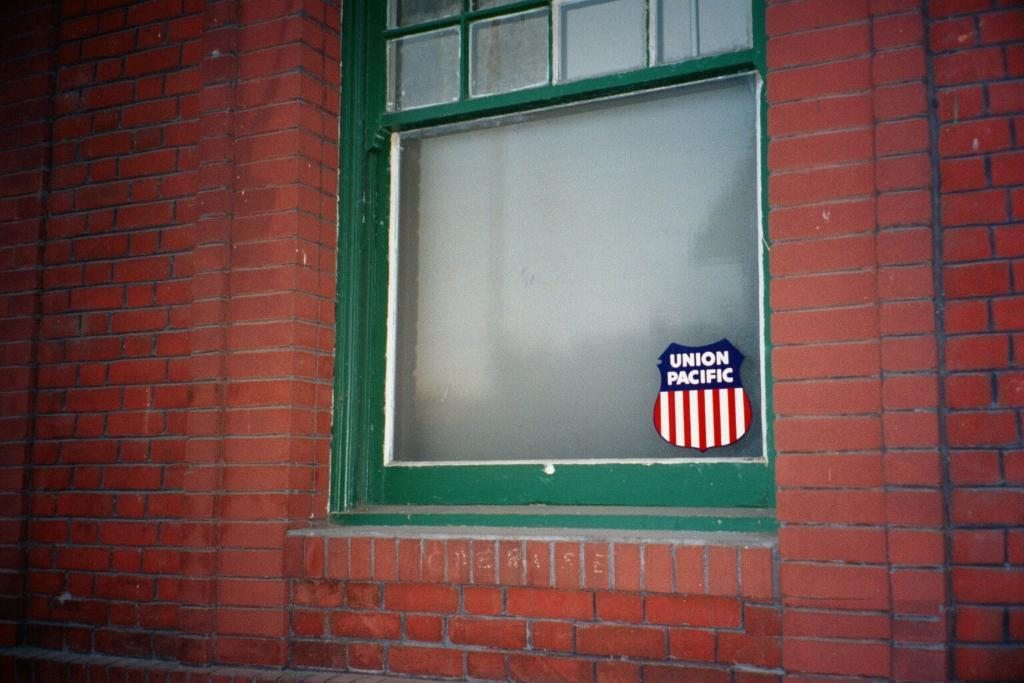Provide a one-sentence caption for the provided image. Union pacific sign that is in a green window of a building. 